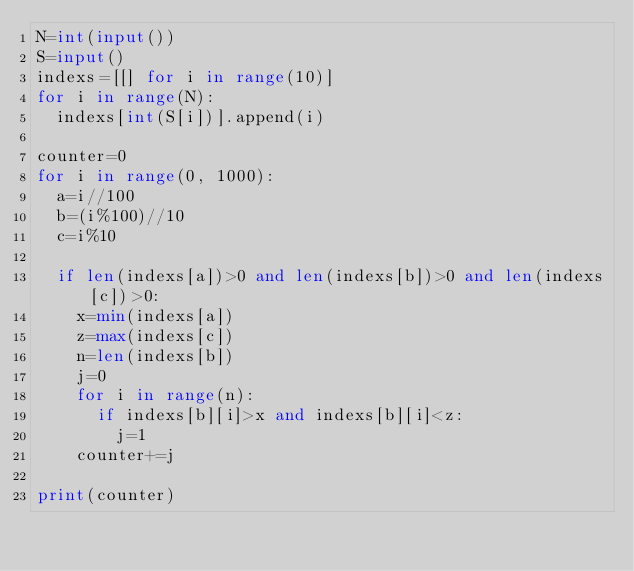<code> <loc_0><loc_0><loc_500><loc_500><_Python_>N=int(input())
S=input()
indexs=[[] for i in range(10)]
for i in range(N):
  indexs[int(S[i])].append(i)

counter=0
for i in range(0, 1000):
  a=i//100
  b=(i%100)//10
  c=i%10

  if len(indexs[a])>0 and len(indexs[b])>0 and len(indexs[c])>0:
    x=min(indexs[a])
    z=max(indexs[c])
    n=len(indexs[b])
    j=0
    for i in range(n):
      if indexs[b][i]>x and indexs[b][i]<z:
        j=1
    counter+=j

print(counter)</code> 